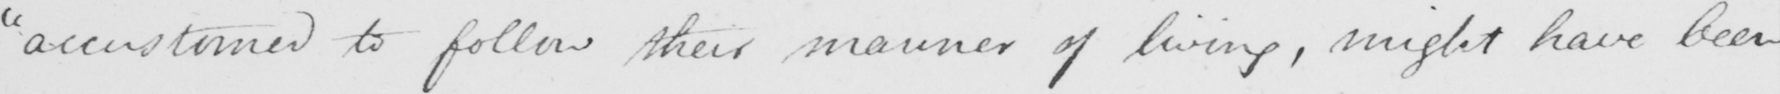Please transcribe the handwritten text in this image. "accustomed to follow their manner of living, might have been 